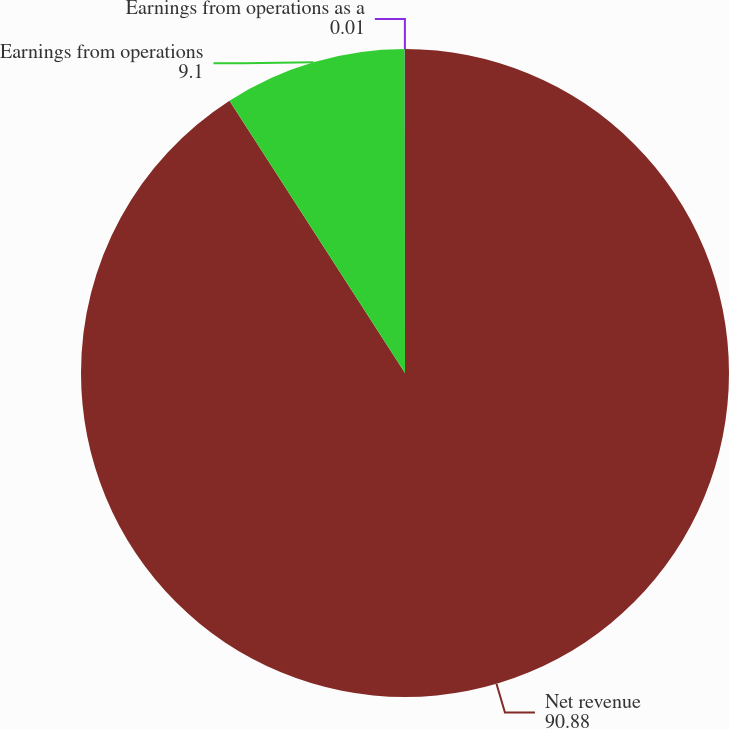<chart> <loc_0><loc_0><loc_500><loc_500><pie_chart><fcel>Net revenue<fcel>Earnings from operations<fcel>Earnings from operations as a<nl><fcel>90.88%<fcel>9.1%<fcel>0.01%<nl></chart> 